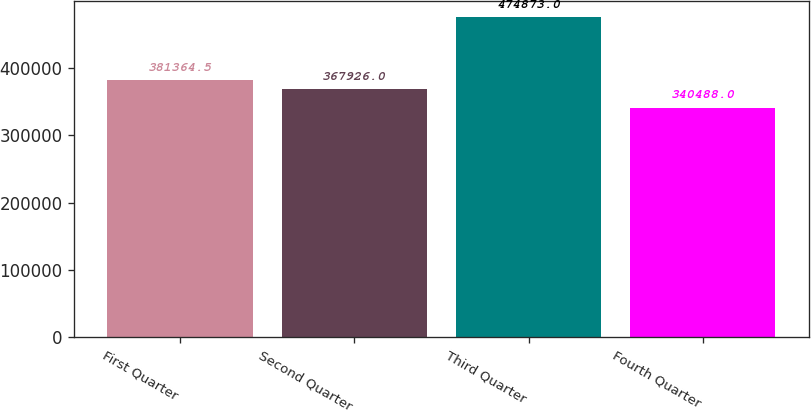Convert chart. <chart><loc_0><loc_0><loc_500><loc_500><bar_chart><fcel>First Quarter<fcel>Second Quarter<fcel>Third Quarter<fcel>Fourth Quarter<nl><fcel>381364<fcel>367926<fcel>474873<fcel>340488<nl></chart> 